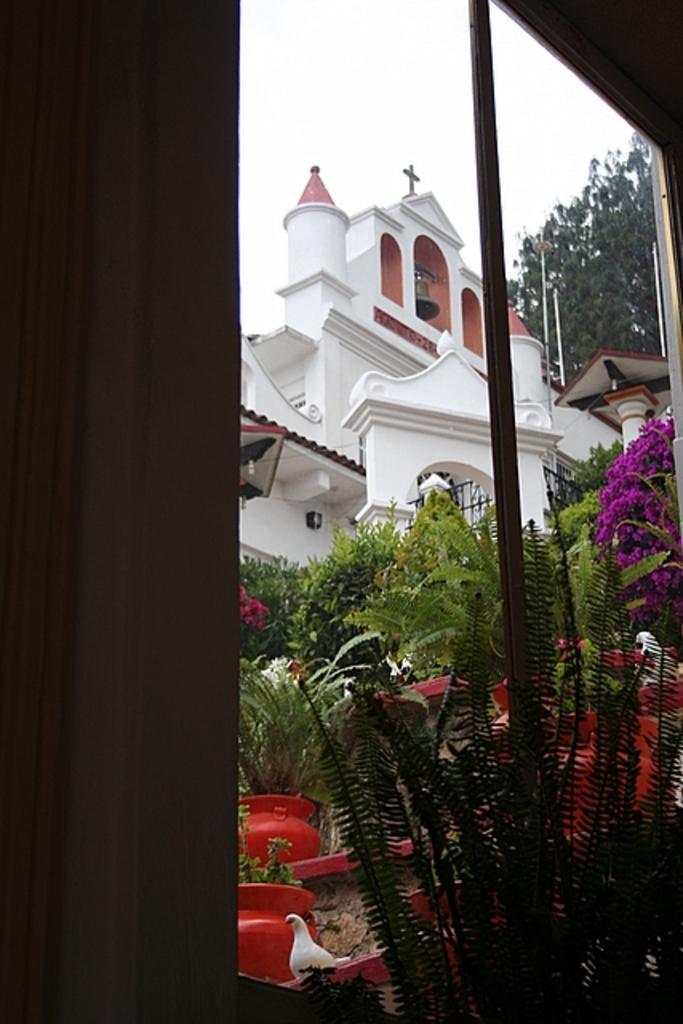Describe this image in one or two sentences. In this picture we can see window, curtain, plants, birds, pots and flowers. In the background of the image we can see building, tree, poles and sky. 